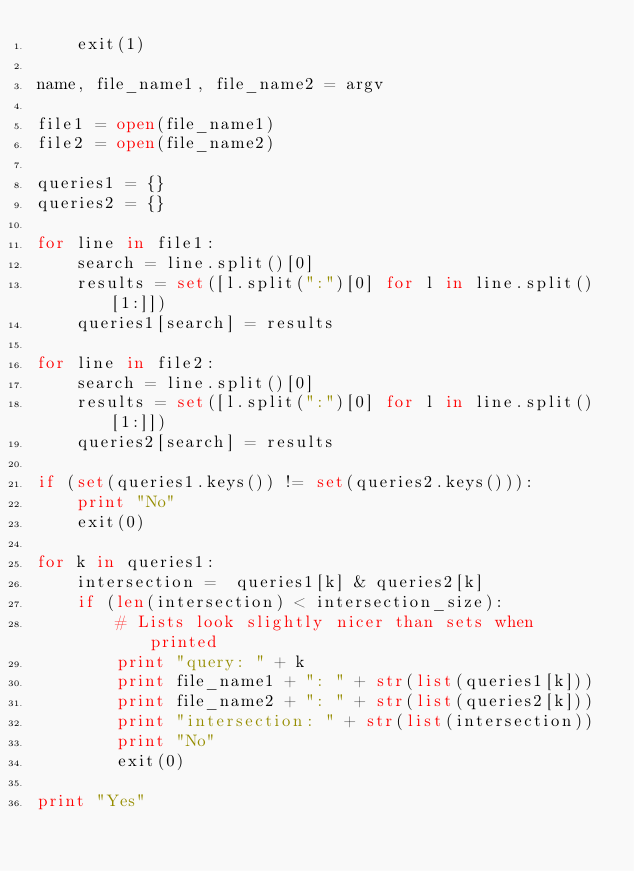Convert code to text. <code><loc_0><loc_0><loc_500><loc_500><_Python_>    exit(1)
    
name, file_name1, file_name2 = argv

file1 = open(file_name1)
file2 = open(file_name2)

queries1 = {}
queries2 = {}

for line in file1:
    search = line.split()[0]
    results = set([l.split(":")[0] for l in line.split()[1:]])
    queries1[search] = results

for line in file2:
    search = line.split()[0]
    results = set([l.split(":")[0] for l in line.split()[1:]])
    queries2[search] = results

if (set(queries1.keys()) != set(queries2.keys())):
    print "No"
    exit(0)

for k in queries1:
    intersection =  queries1[k] & queries2[k]
    if (len(intersection) < intersection_size):
        # Lists look slightly nicer than sets when printed
        print "query: " + k
        print file_name1 + ": " + str(list(queries1[k]))
        print file_name2 + ": " + str(list(queries2[k]))
        print "intersection: " + str(list(intersection))
        print "No"
        exit(0)

print "Yes"
</code> 